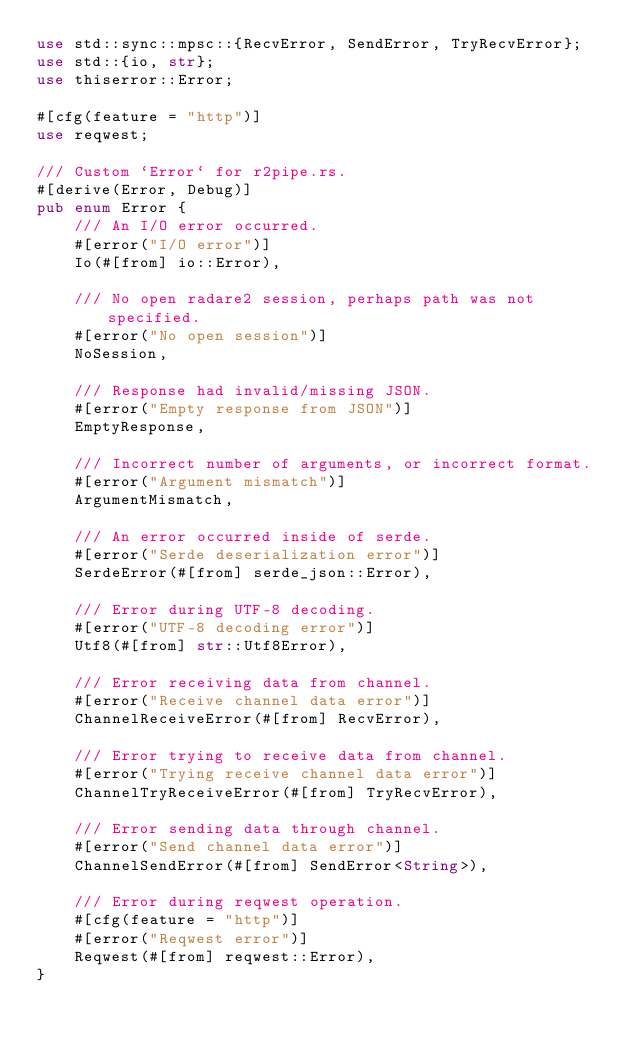Convert code to text. <code><loc_0><loc_0><loc_500><loc_500><_Rust_>use std::sync::mpsc::{RecvError, SendError, TryRecvError};
use std::{io, str};
use thiserror::Error;

#[cfg(feature = "http")]
use reqwest;

/// Custom `Error` for r2pipe.rs.
#[derive(Error, Debug)]
pub enum Error {
    /// An I/O error occurred.
    #[error("I/O error")]
    Io(#[from] io::Error),

    /// No open radare2 session, perhaps path was not specified.
    #[error("No open session")]
    NoSession,

    /// Response had invalid/missing JSON.
    #[error("Empty response from JSON")]
    EmptyResponse,

    /// Incorrect number of arguments, or incorrect format.
    #[error("Argument mismatch")]
    ArgumentMismatch,

    /// An error occurred inside of serde.
    #[error("Serde deserialization error")]
    SerdeError(#[from] serde_json::Error),

    /// Error during UTF-8 decoding.
    #[error("UTF-8 decoding error")]
    Utf8(#[from] str::Utf8Error),

    /// Error receiving data from channel.
    #[error("Receive channel data error")]
    ChannelReceiveError(#[from] RecvError),

    /// Error trying to receive data from channel.
    #[error("Trying receive channel data error")]
    ChannelTryReceiveError(#[from] TryRecvError),

    /// Error sending data through channel.
    #[error("Send channel data error")]
    ChannelSendError(#[from] SendError<String>),

    /// Error during reqwest operation.
    #[cfg(feature = "http")]
    #[error("Reqwest error")]
    Reqwest(#[from] reqwest::Error),
}
</code> 